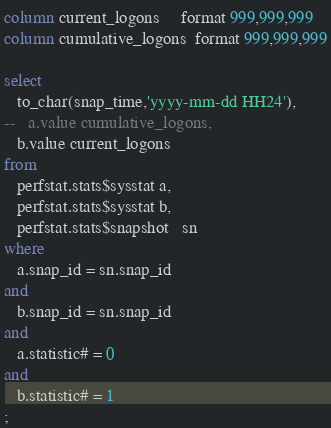<code> <loc_0><loc_0><loc_500><loc_500><_SQL_>column current_logons     format 999,999,999
column cumulative_logons  format 999,999,999

select
   to_char(snap_time,'yyyy-mm-dd HH24'),
--   a.value cumulative_logons,
   b.value current_logons
from 
   perfstat.stats$sysstat a, 
   perfstat.stats$sysstat b, 
   perfstat.stats$snapshot   sn
where
   a.snap_id = sn.snap_id
and
   b.snap_id = sn.snap_id
and
   a.statistic# = 0
and
   b.statistic# = 1
;

</code> 